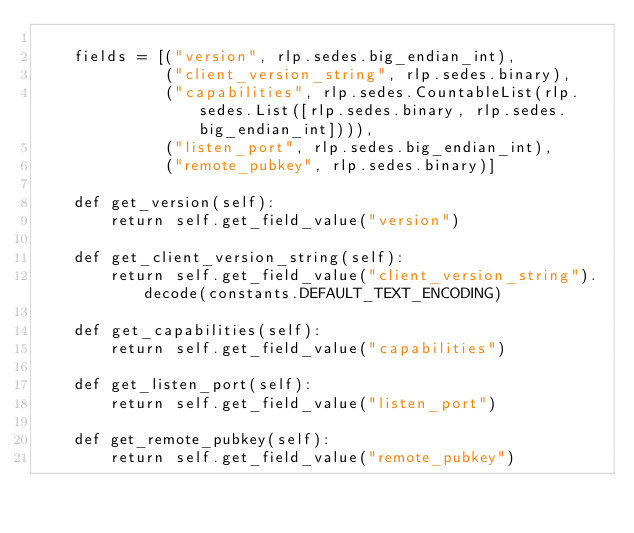Convert code to text. <code><loc_0><loc_0><loc_500><loc_500><_Python_>
    fields = [("version", rlp.sedes.big_endian_int),
              ("client_version_string", rlp.sedes.binary),
              ("capabilities", rlp.sedes.CountableList(rlp.sedes.List([rlp.sedes.binary, rlp.sedes.big_endian_int]))),
              ("listen_port", rlp.sedes.big_endian_int),
              ("remote_pubkey", rlp.sedes.binary)]

    def get_version(self):
        return self.get_field_value("version")

    def get_client_version_string(self):
        return self.get_field_value("client_version_string").decode(constants.DEFAULT_TEXT_ENCODING)

    def get_capabilities(self):
        return self.get_field_value("capabilities")

    def get_listen_port(self):
        return self.get_field_value("listen_port")

    def get_remote_pubkey(self):
        return self.get_field_value("remote_pubkey")
</code> 